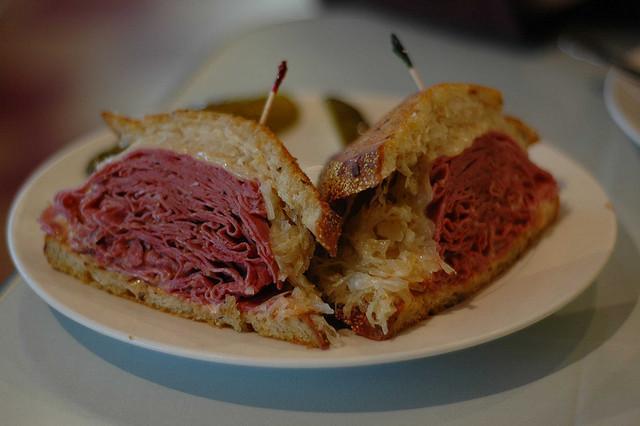What's the purpose of the little sticks?
Select the accurate response from the four choices given to answer the question.
Options: Decoration, keep together, add flavor, test doneness. Keep together. 